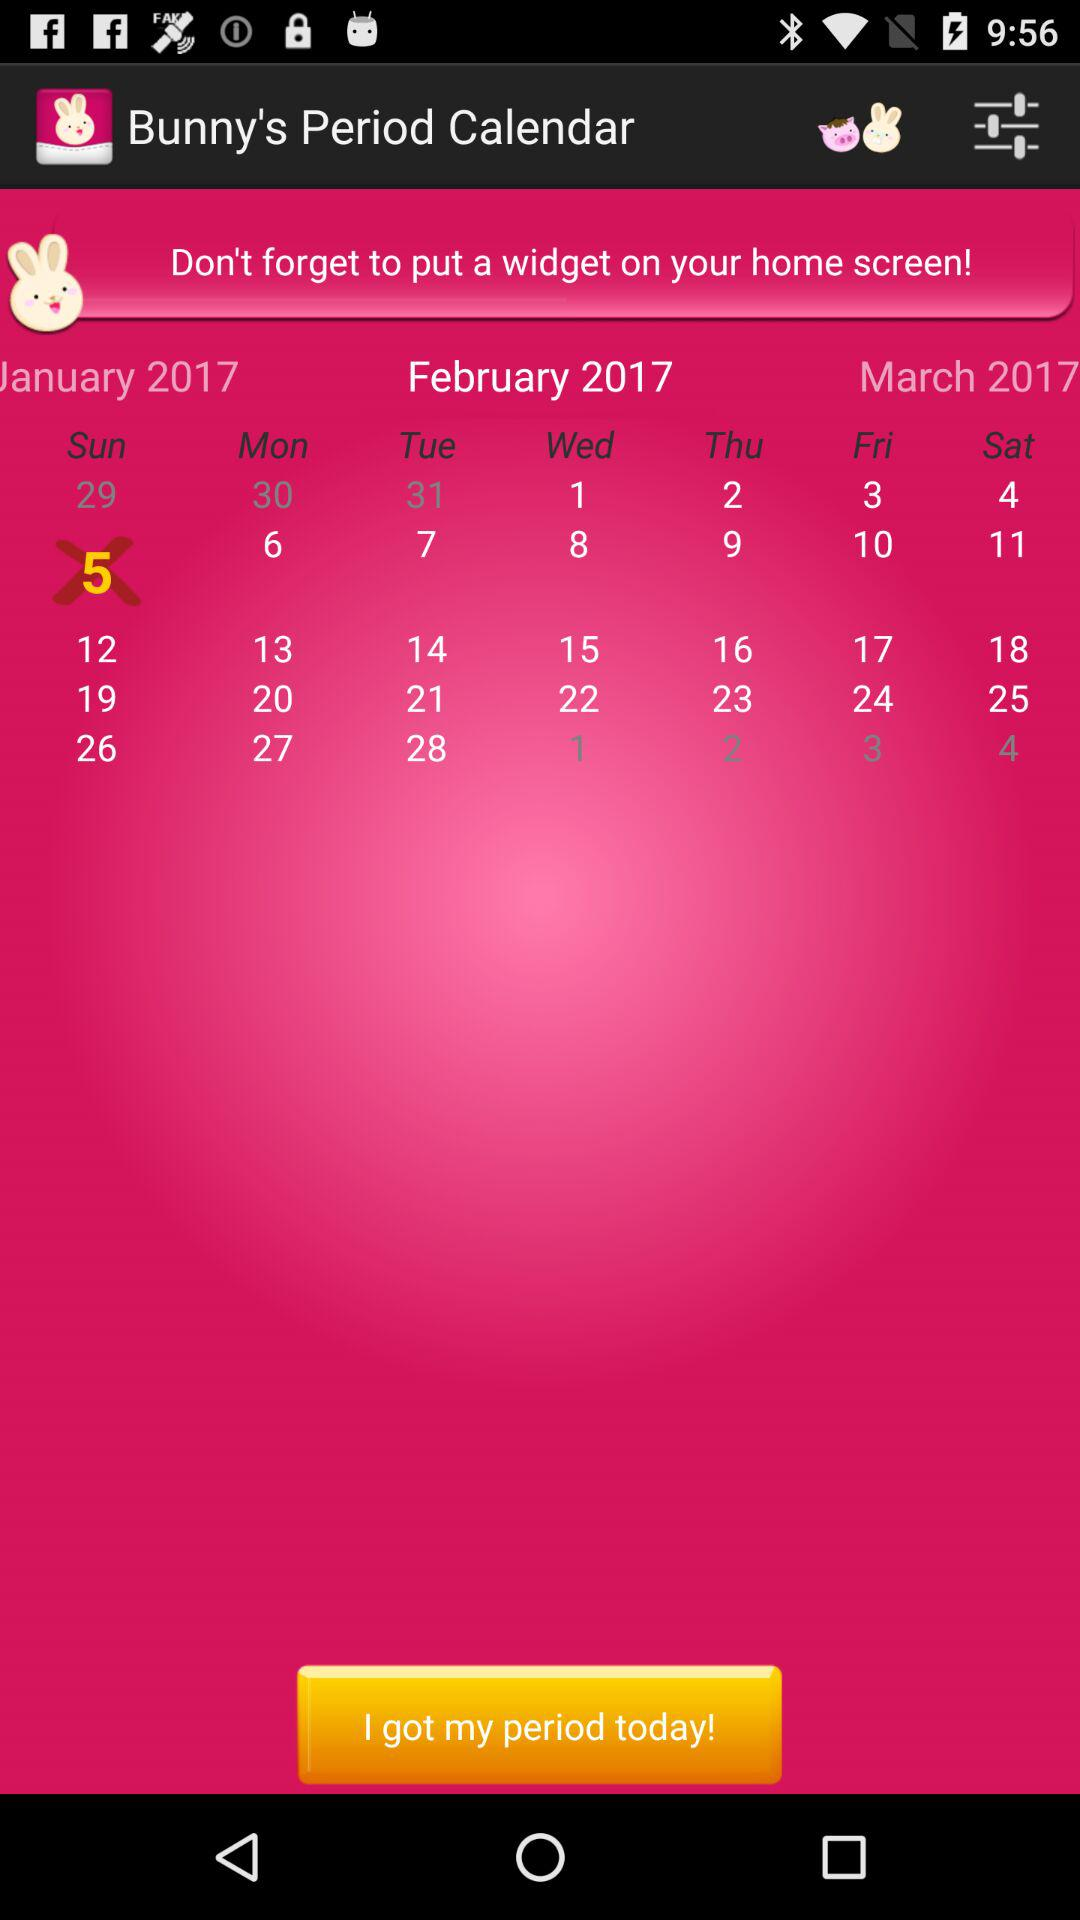Which date of the month is highlighted? The highlighted date of the month is Sunday, February 5, 2017. 